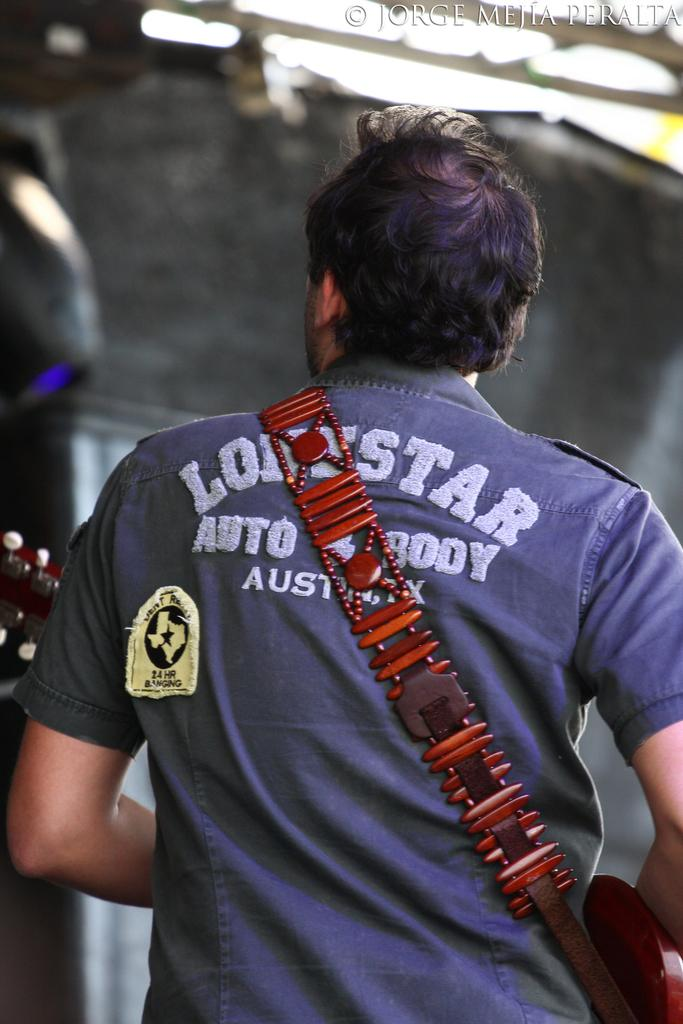<image>
Provide a brief description of the given image. A person wearing a Lonestar Auto & Body shop shirt is holding a guitar. 